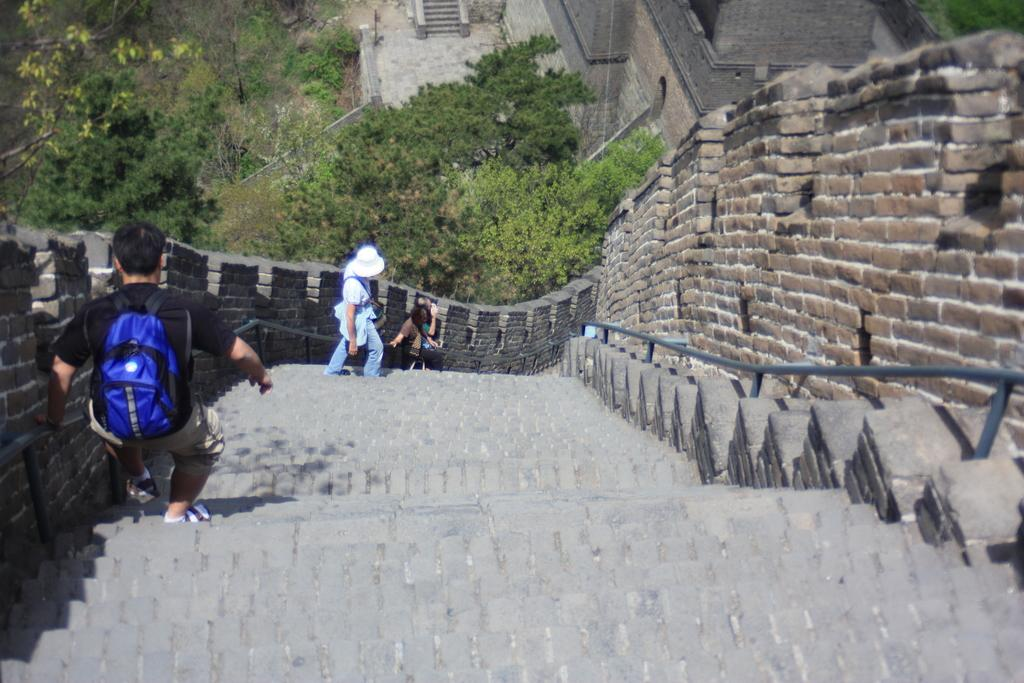Who is present in the image? There are people in the image. What are the people doing in the image? The people are getting down the stairs. Where are the stairs located? The stairs are on the Great Wall of China. What can be seen on the other side of the wall? There are trees on the other side of the wall. What type of animal is running alongside the people in the image? There are no animals present in the image, and the people are not running. 